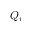<formula> <loc_0><loc_0><loc_500><loc_500>Q _ { r }</formula> 